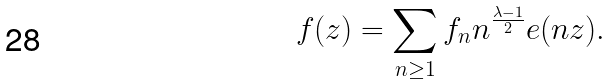Convert formula to latex. <formula><loc_0><loc_0><loc_500><loc_500>f ( z ) = \sum _ { n \geq 1 } f _ { n } n ^ { \frac { \lambda - 1 } { 2 } } e ( n z ) .</formula> 